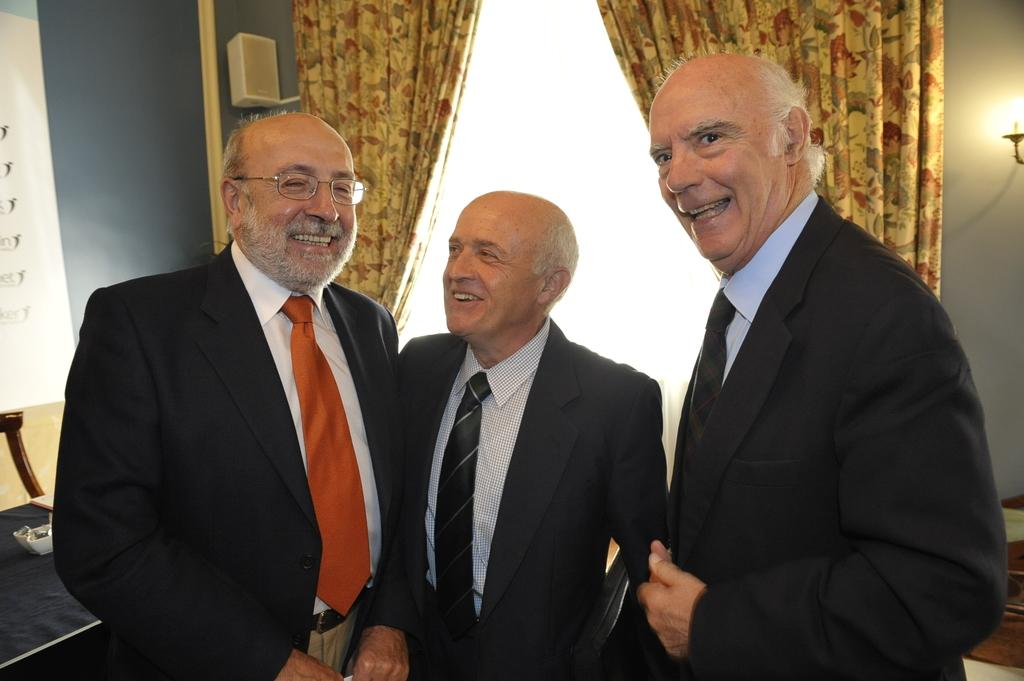How many people are in the image? There are three persons standing in the image. What is the facial expression of the persons in the image? The persons are smiling. What type of window treatment is visible in the image? There are curtains in the image. What is the source of light in the image? There is a light in the image. What device is present for amplifying sound? There is a speaker in the image. What type of nut is being used to fuel the coal in the image? There is no nut or coal present in the image. 